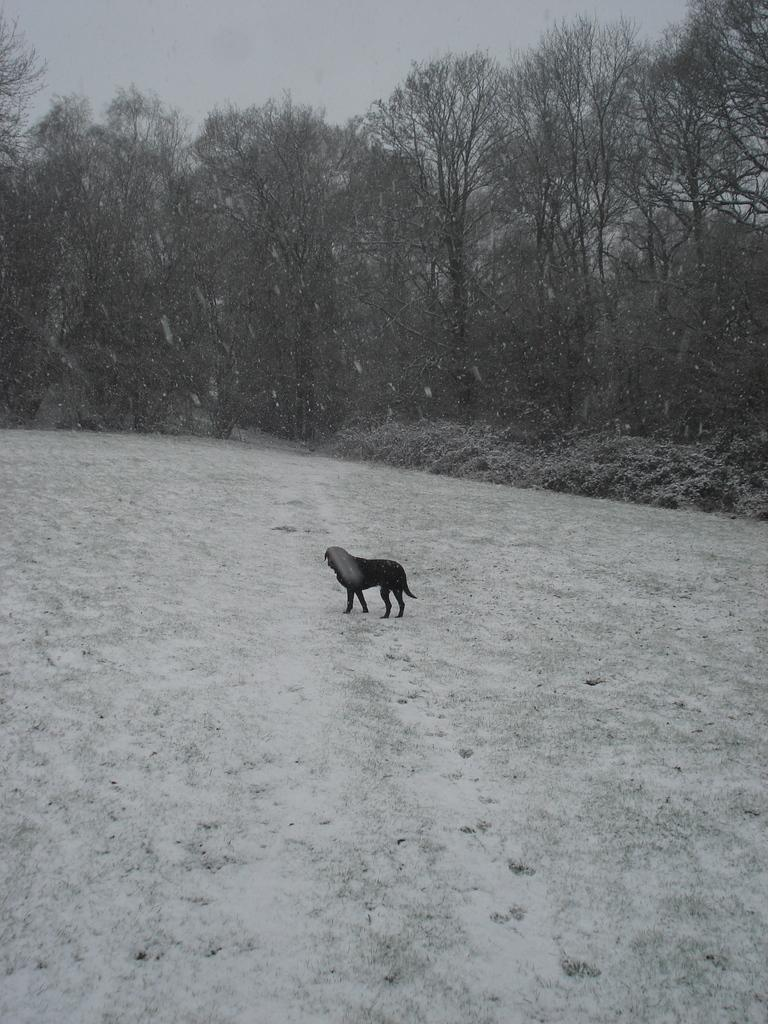What is present at the bottom of the image? There is snow at the bottom of the image. What is the main subject in the center of the image? There is a dog in the center of the image. What can be seen in the background of the image? There are trees and plants in the background of the image. Can you see any bees buzzing around the dog in the image? There are no bees present in the image. What type of linen is draped over the trees in the background? There is no linen present in the image; it only features a dog, snow, trees, and plants. 